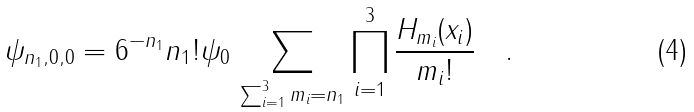<formula> <loc_0><loc_0><loc_500><loc_500>\psi _ { n _ { 1 } , 0 , 0 } = 6 ^ { - n _ { 1 } } n _ { 1 } ! \psi _ { 0 } \, \sum _ { \sum _ { i = 1 } ^ { 3 } m _ { i } = n _ { 1 } } \prod _ { i = 1 } ^ { 3 } \frac { H _ { m _ { i } } ( x _ { i } ) } { m _ { i } ! } \quad .</formula> 